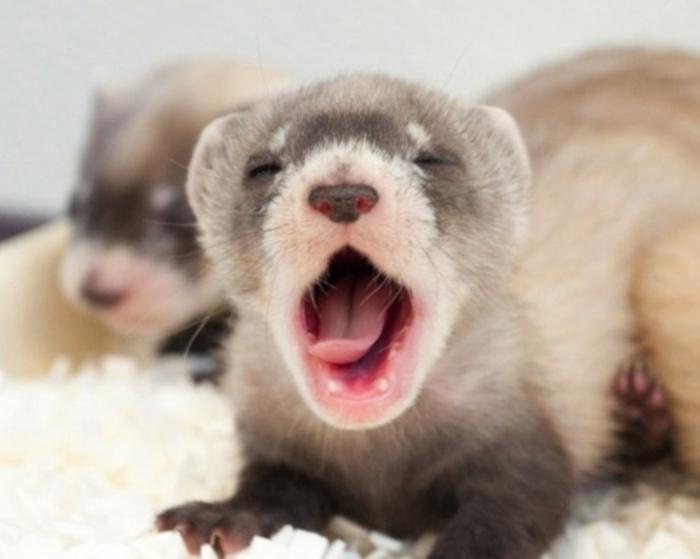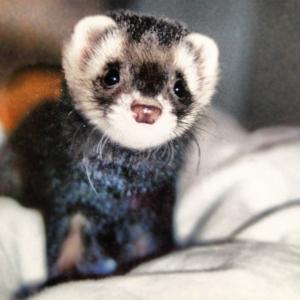The first image is the image on the left, the second image is the image on the right. Examine the images to the left and right. Is the description "At least two ferrets are playing." accurate? Answer yes or no. No. The first image is the image on the left, the second image is the image on the right. Examine the images to the left and right. Is the description "There are more than 4 ferrets interacting." accurate? Answer yes or no. No. 